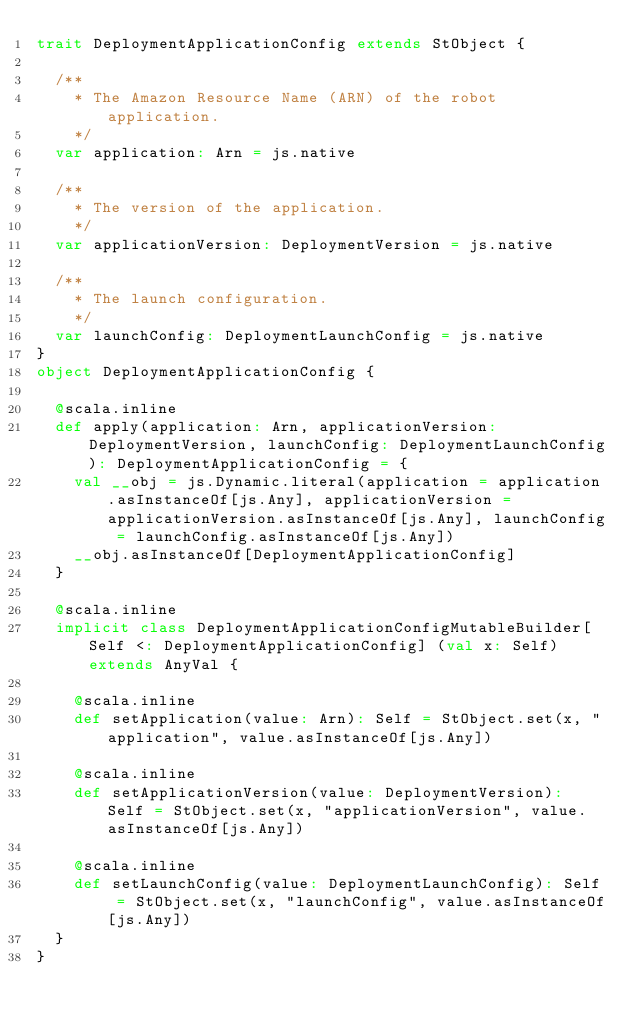<code> <loc_0><loc_0><loc_500><loc_500><_Scala_>trait DeploymentApplicationConfig extends StObject {
  
  /**
    * The Amazon Resource Name (ARN) of the robot application.
    */
  var application: Arn = js.native
  
  /**
    * The version of the application.
    */
  var applicationVersion: DeploymentVersion = js.native
  
  /**
    * The launch configuration.
    */
  var launchConfig: DeploymentLaunchConfig = js.native
}
object DeploymentApplicationConfig {
  
  @scala.inline
  def apply(application: Arn, applicationVersion: DeploymentVersion, launchConfig: DeploymentLaunchConfig): DeploymentApplicationConfig = {
    val __obj = js.Dynamic.literal(application = application.asInstanceOf[js.Any], applicationVersion = applicationVersion.asInstanceOf[js.Any], launchConfig = launchConfig.asInstanceOf[js.Any])
    __obj.asInstanceOf[DeploymentApplicationConfig]
  }
  
  @scala.inline
  implicit class DeploymentApplicationConfigMutableBuilder[Self <: DeploymentApplicationConfig] (val x: Self) extends AnyVal {
    
    @scala.inline
    def setApplication(value: Arn): Self = StObject.set(x, "application", value.asInstanceOf[js.Any])
    
    @scala.inline
    def setApplicationVersion(value: DeploymentVersion): Self = StObject.set(x, "applicationVersion", value.asInstanceOf[js.Any])
    
    @scala.inline
    def setLaunchConfig(value: DeploymentLaunchConfig): Self = StObject.set(x, "launchConfig", value.asInstanceOf[js.Any])
  }
}
</code> 